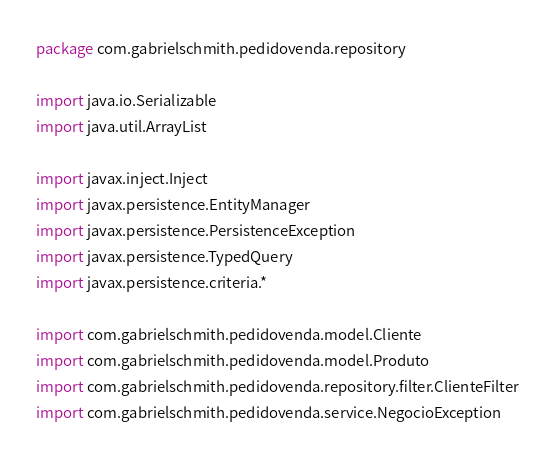<code> <loc_0><loc_0><loc_500><loc_500><_Kotlin_>package com.gabrielschmith.pedidovenda.repository

import java.io.Serializable
import java.util.ArrayList

import javax.inject.Inject
import javax.persistence.EntityManager
import javax.persistence.PersistenceException
import javax.persistence.TypedQuery
import javax.persistence.criteria.*

import com.gabrielschmith.pedidovenda.model.Cliente
import com.gabrielschmith.pedidovenda.model.Produto
import com.gabrielschmith.pedidovenda.repository.filter.ClienteFilter
import com.gabrielschmith.pedidovenda.service.NegocioException</code> 